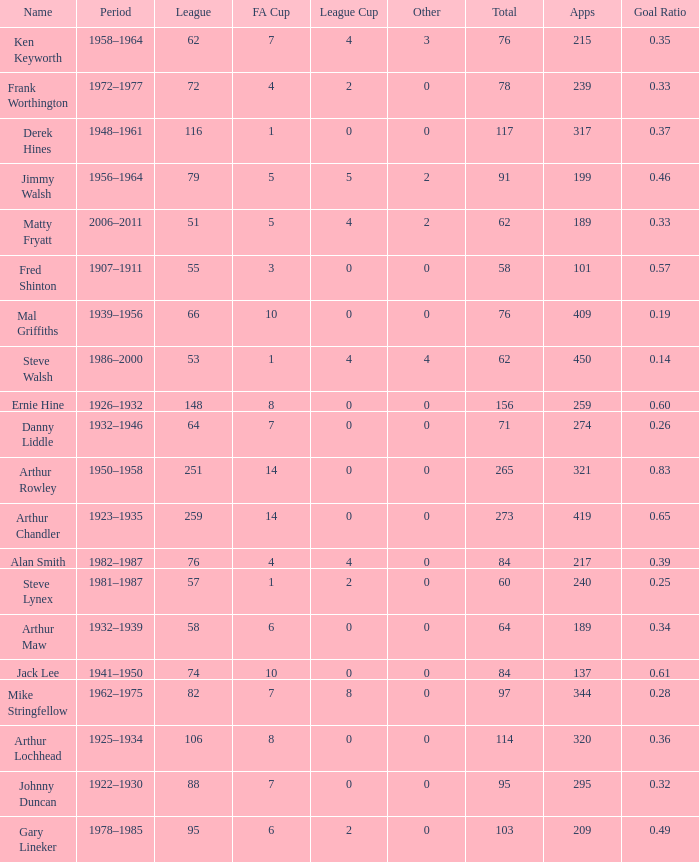What's the highest FA Cup with the Name of Alan Smith, and League Cup smaller than 4? None. 